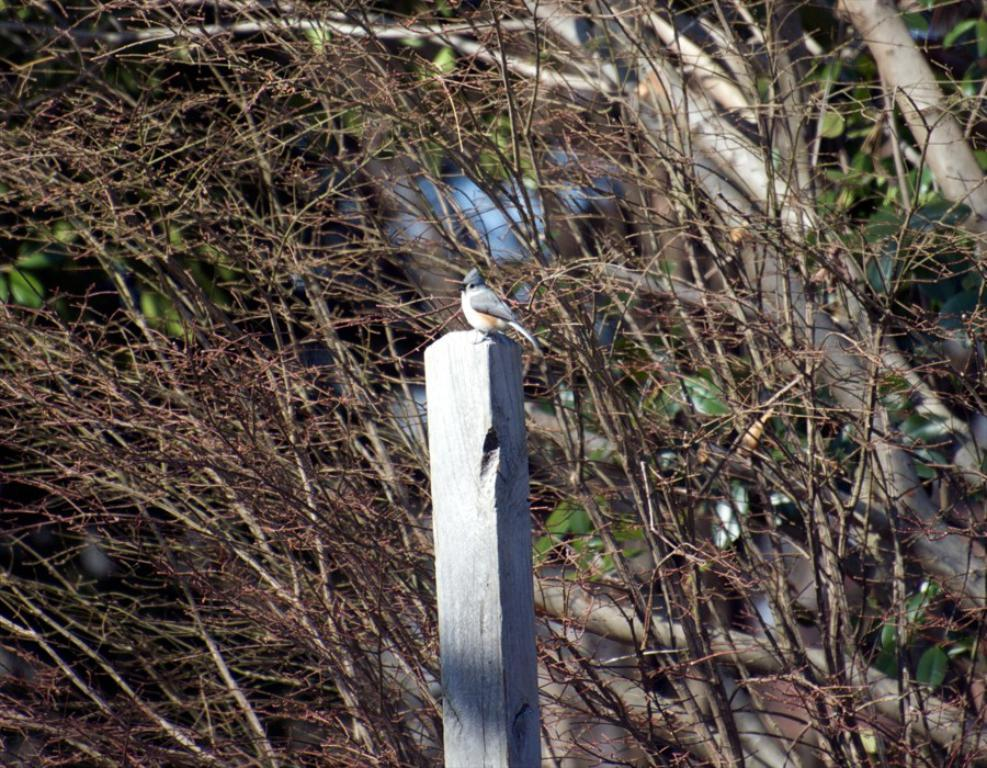What type of animal can be seen in the image? There is a bird in the image. Where is the bird located in the image? The bird is standing on a wooden rafter. What can be seen in the background of the image? Trees and plants are visible in the background of the image. What color are the leaves visible on the right side of the image? The leaves visible on the right side of the image are green. What type of treatment is the bird receiving on the sofa in the image? There is no sofa or treatment present in the image; it features a bird standing on a wooden rafter. 